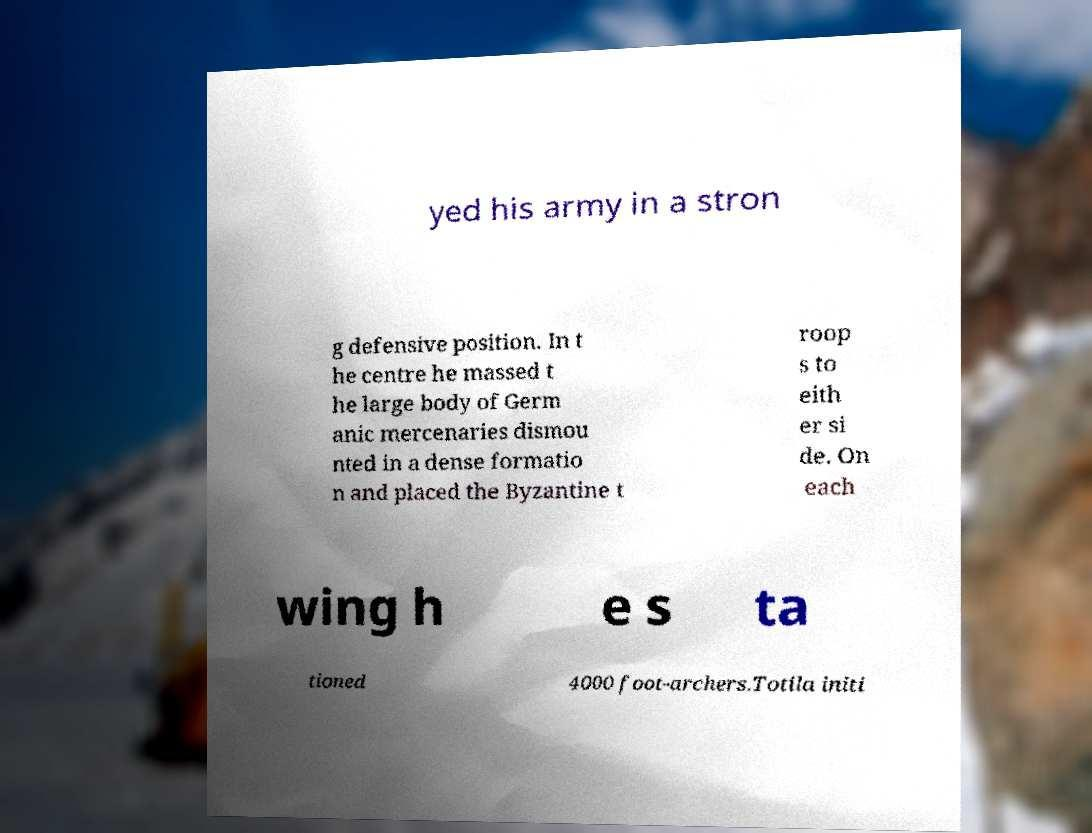Could you extract and type out the text from this image? yed his army in a stron g defensive position. In t he centre he massed t he large body of Germ anic mercenaries dismou nted in a dense formatio n and placed the Byzantine t roop s to eith er si de. On each wing h e s ta tioned 4000 foot-archers.Totila initi 